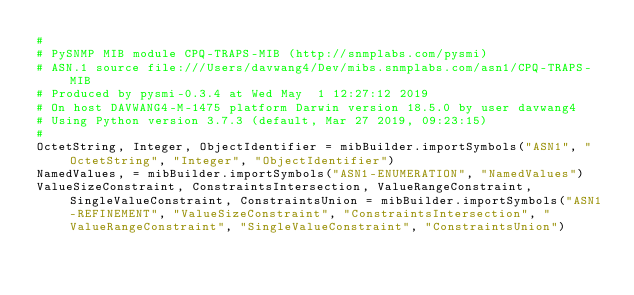<code> <loc_0><loc_0><loc_500><loc_500><_Python_>#
# PySNMP MIB module CPQ-TRAPS-MIB (http://snmplabs.com/pysmi)
# ASN.1 source file:///Users/davwang4/Dev/mibs.snmplabs.com/asn1/CPQ-TRAPS-MIB
# Produced by pysmi-0.3.4 at Wed May  1 12:27:12 2019
# On host DAVWANG4-M-1475 platform Darwin version 18.5.0 by user davwang4
# Using Python version 3.7.3 (default, Mar 27 2019, 09:23:15) 
#
OctetString, Integer, ObjectIdentifier = mibBuilder.importSymbols("ASN1", "OctetString", "Integer", "ObjectIdentifier")
NamedValues, = mibBuilder.importSymbols("ASN1-ENUMERATION", "NamedValues")
ValueSizeConstraint, ConstraintsIntersection, ValueRangeConstraint, SingleValueConstraint, ConstraintsUnion = mibBuilder.importSymbols("ASN1-REFINEMENT", "ValueSizeConstraint", "ConstraintsIntersection", "ValueRangeConstraint", "SingleValueConstraint", "ConstraintsUnion")</code> 